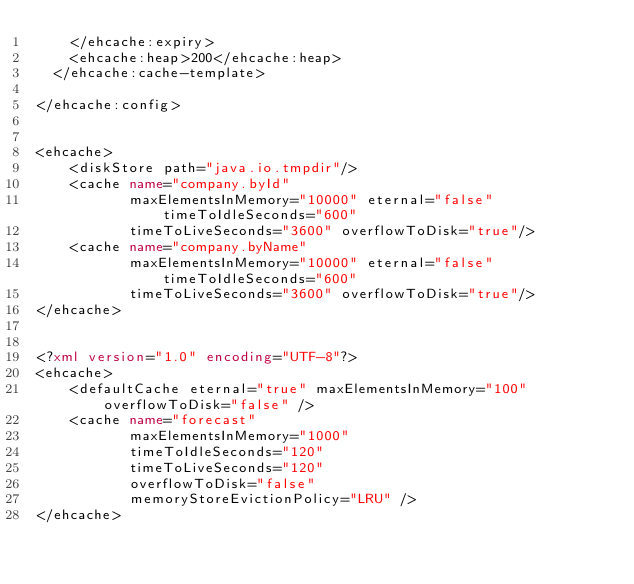<code> <loc_0><loc_0><loc_500><loc_500><_XML_>		</ehcache:expiry>
		<ehcache:heap>200</ehcache:heap>
	</ehcache:cache-template>

</ehcache:config>


<ehcache>
    <diskStore path="java.io.tmpdir"/>
    <cache name="company.byId"
           maxElementsInMemory="10000" eternal="false" timeToIdleSeconds="600"
           timeToLiveSeconds="3600" overflowToDisk="true"/>
    <cache name="company.byName"
           maxElementsInMemory="10000" eternal="false" timeToIdleSeconds="600"
           timeToLiveSeconds="3600" overflowToDisk="true"/>
</ehcache>


<?xml version="1.0" encoding="UTF-8"?>
<ehcache>
    <defaultCache eternal="true" maxElementsInMemory="100" overflowToDisk="false" />
    <cache name="forecast" 
           maxElementsInMemory="1000" 
           timeToIdleSeconds="120"
           timeToLiveSeconds="120"
           overflowToDisk="false"
           memoryStoreEvictionPolicy="LRU" />
</ehcache>
</code> 